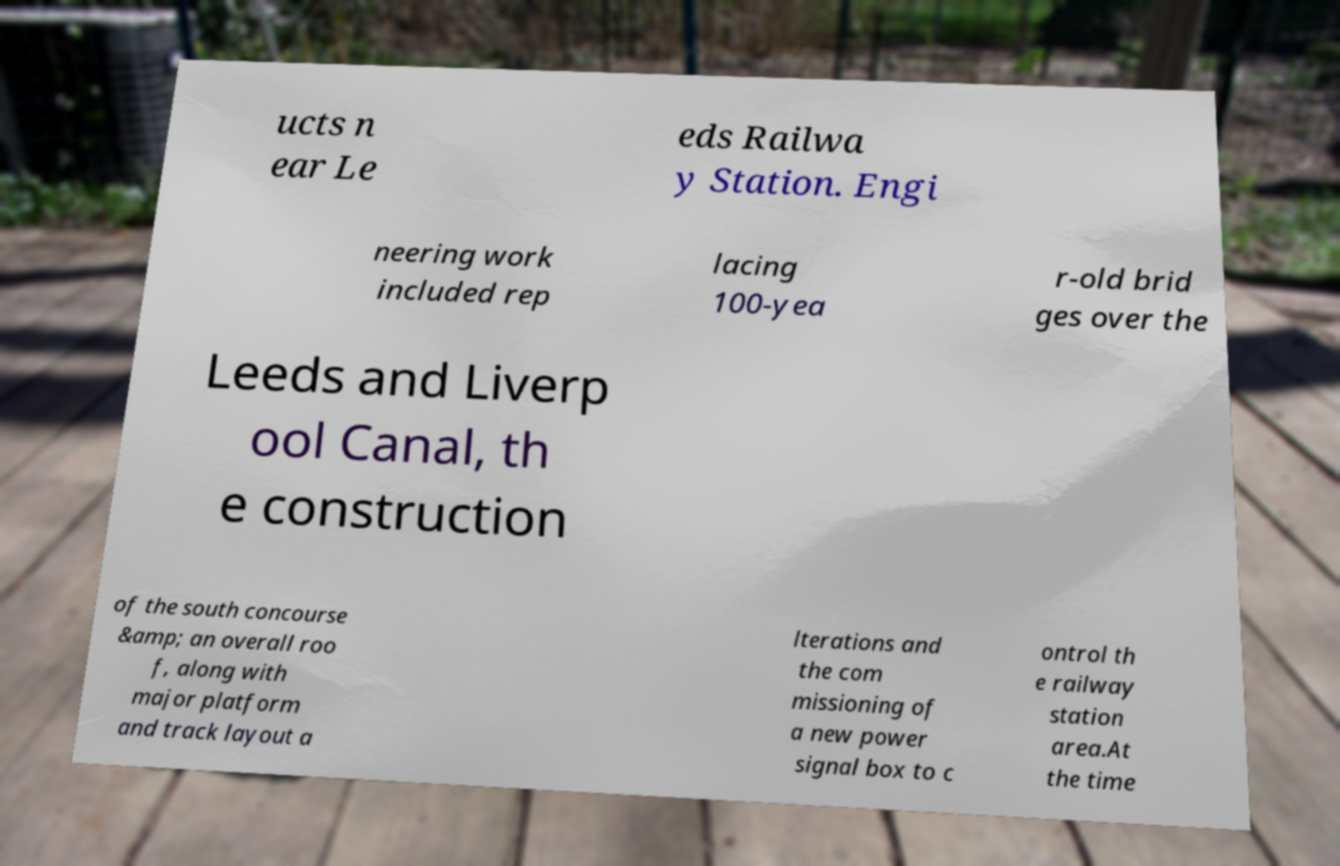Can you read and provide the text displayed in the image?This photo seems to have some interesting text. Can you extract and type it out for me? ucts n ear Le eds Railwa y Station. Engi neering work included rep lacing 100-yea r-old brid ges over the Leeds and Liverp ool Canal, th e construction of the south concourse &amp; an overall roo f, along with major platform and track layout a lterations and the com missioning of a new power signal box to c ontrol th e railway station area.At the time 